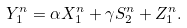<formula> <loc_0><loc_0><loc_500><loc_500>Y ^ { n } _ { 1 } = \alpha X ^ { n } _ { 1 } + \gamma S ^ { n } _ { 2 } + Z ^ { n } _ { 1 } .</formula> 